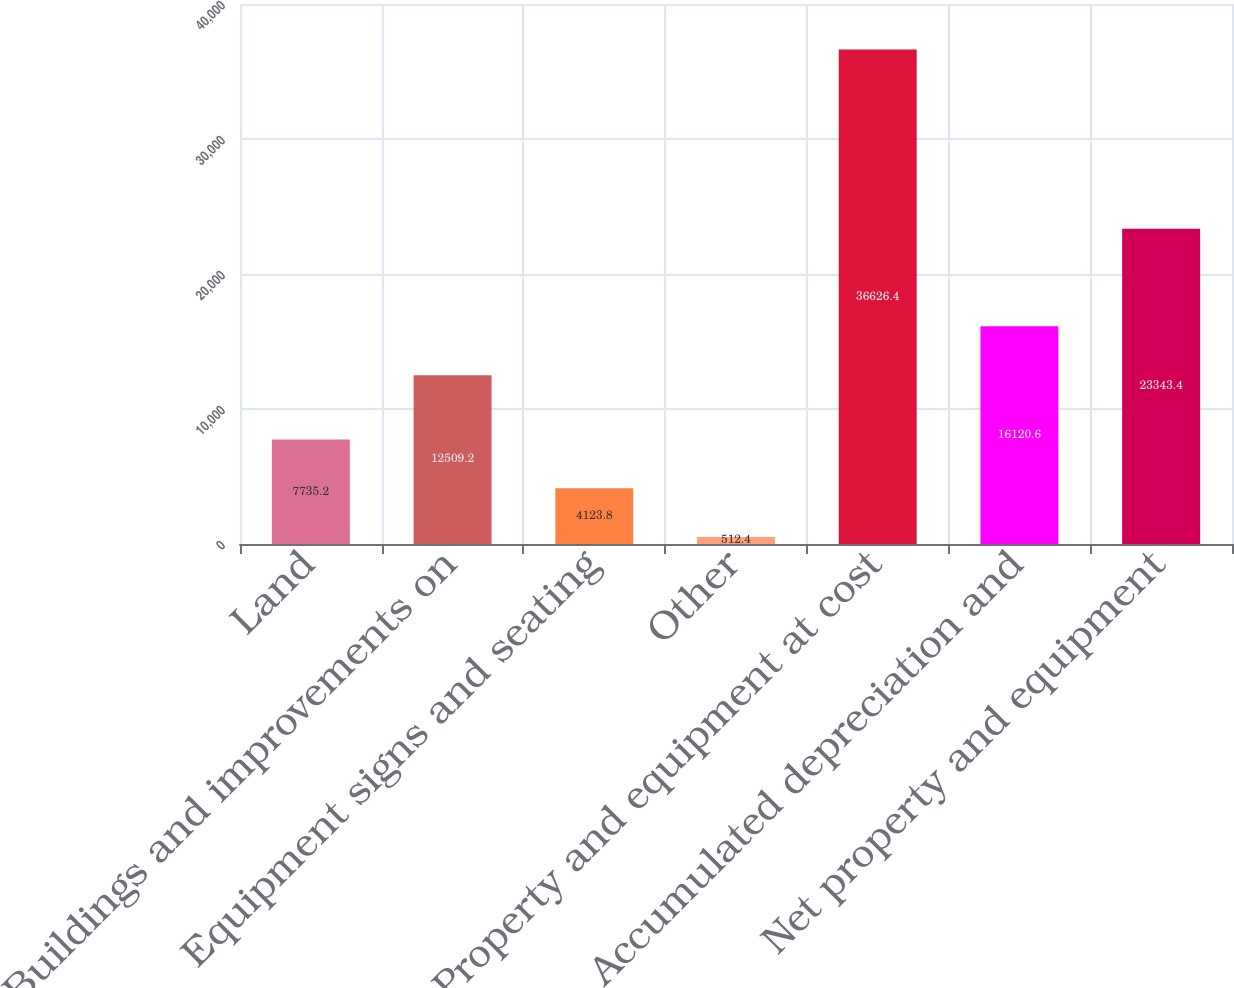<chart> <loc_0><loc_0><loc_500><loc_500><bar_chart><fcel>Land<fcel>Buildings and improvements on<fcel>Equipment signs and seating<fcel>Other<fcel>Property and equipment at cost<fcel>Accumulated depreciation and<fcel>Net property and equipment<nl><fcel>7735.2<fcel>12509.2<fcel>4123.8<fcel>512.4<fcel>36626.4<fcel>16120.6<fcel>23343.4<nl></chart> 